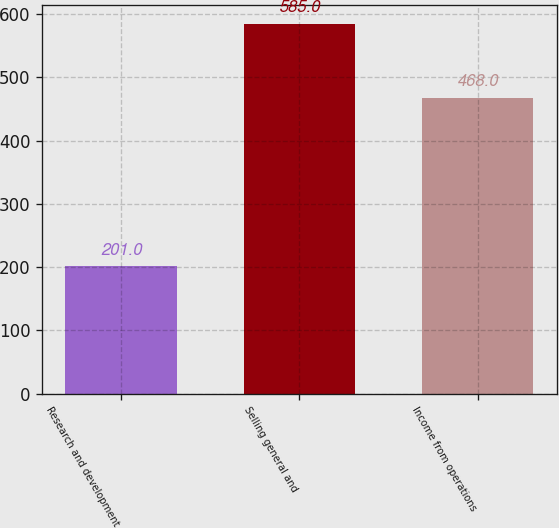Convert chart. <chart><loc_0><loc_0><loc_500><loc_500><bar_chart><fcel>Research and development<fcel>Selling general and<fcel>Income from operations<nl><fcel>201<fcel>585<fcel>468<nl></chart> 